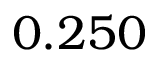Convert formula to latex. <formula><loc_0><loc_0><loc_500><loc_500>0 . 2 5 0</formula> 